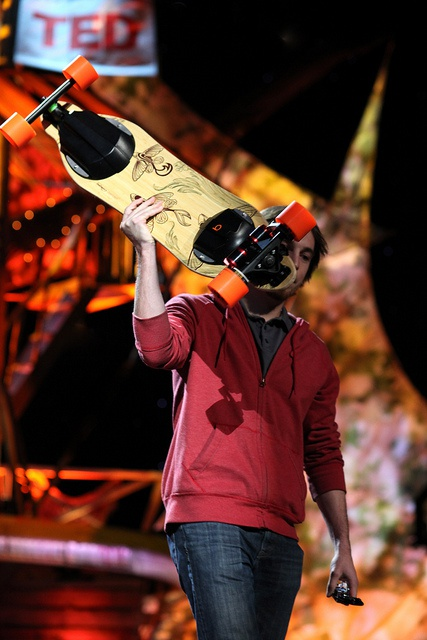Describe the objects in this image and their specific colors. I can see people in maroon, black, and brown tones, skateboard in maroon, black, khaki, tan, and red tones, and cell phone in maroon, black, gray, and darkgray tones in this image. 